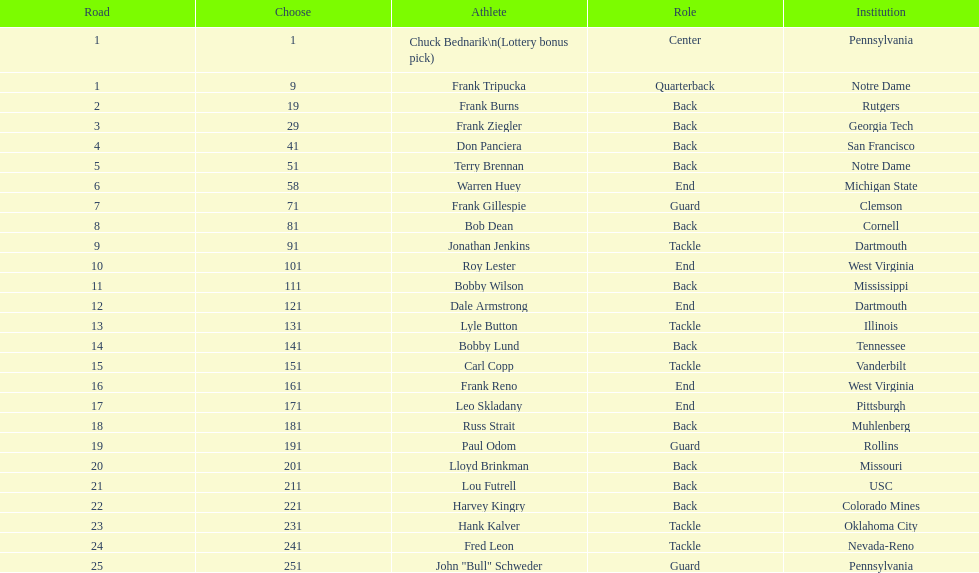What was the position that most of the players had? Back. 